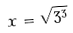<formula> <loc_0><loc_0><loc_500><loc_500>x = \sqrt { 3 ^ { 3 } }</formula> 